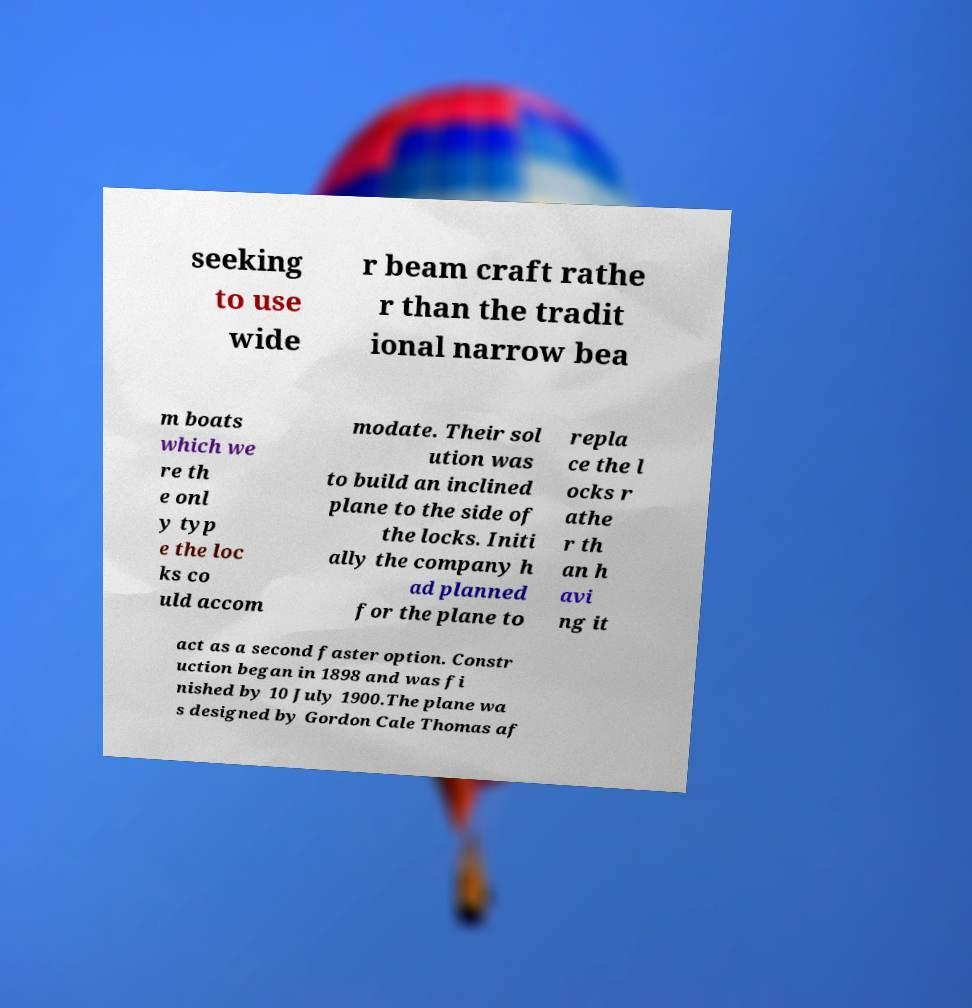Could you assist in decoding the text presented in this image and type it out clearly? seeking to use wide r beam craft rathe r than the tradit ional narrow bea m boats which we re th e onl y typ e the loc ks co uld accom modate. Their sol ution was to build an inclined plane to the side of the locks. Initi ally the company h ad planned for the plane to repla ce the l ocks r athe r th an h avi ng it act as a second faster option. Constr uction began in 1898 and was fi nished by 10 July 1900.The plane wa s designed by Gordon Cale Thomas af 